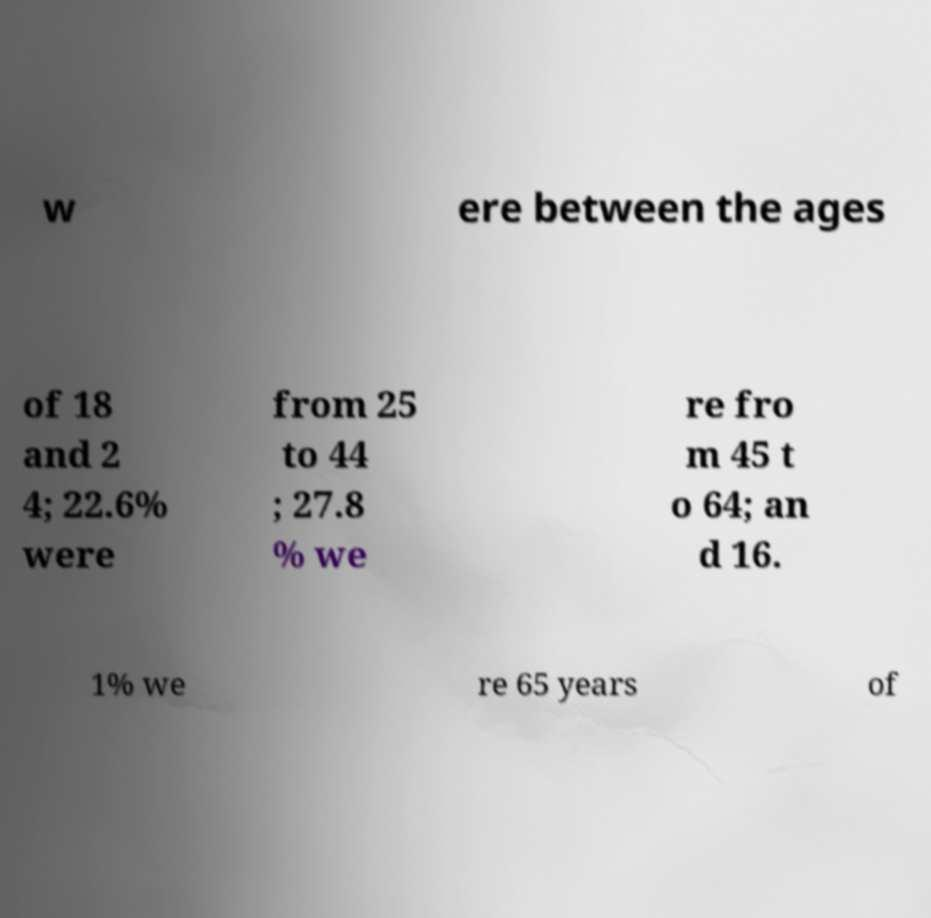Can you accurately transcribe the text from the provided image for me? w ere between the ages of 18 and 2 4; 22.6% were from 25 to 44 ; 27.8 % we re fro m 45 t o 64; an d 16. 1% we re 65 years of 